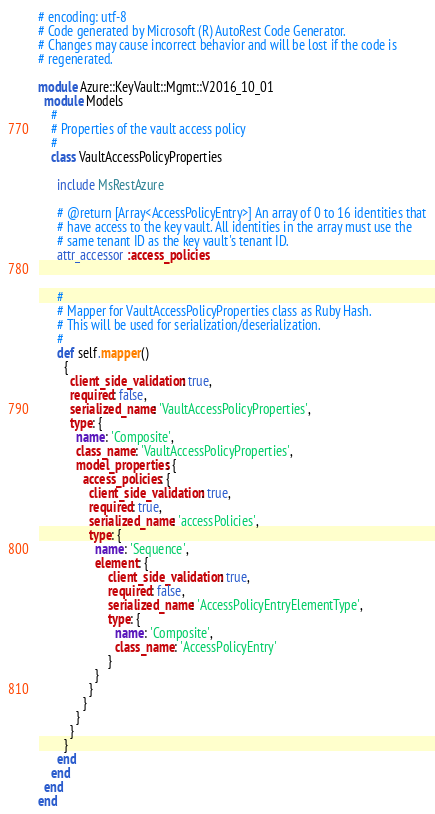Convert code to text. <code><loc_0><loc_0><loc_500><loc_500><_Ruby_># encoding: utf-8
# Code generated by Microsoft (R) AutoRest Code Generator.
# Changes may cause incorrect behavior and will be lost if the code is
# regenerated.

module Azure::KeyVault::Mgmt::V2016_10_01
  module Models
    #
    # Properties of the vault access policy
    #
    class VaultAccessPolicyProperties

      include MsRestAzure

      # @return [Array<AccessPolicyEntry>] An array of 0 to 16 identities that
      # have access to the key vault. All identities in the array must use the
      # same tenant ID as the key vault's tenant ID.
      attr_accessor :access_policies


      #
      # Mapper for VaultAccessPolicyProperties class as Ruby Hash.
      # This will be used for serialization/deserialization.
      #
      def self.mapper()
        {
          client_side_validation: true,
          required: false,
          serialized_name: 'VaultAccessPolicyProperties',
          type: {
            name: 'Composite',
            class_name: 'VaultAccessPolicyProperties',
            model_properties: {
              access_policies: {
                client_side_validation: true,
                required: true,
                serialized_name: 'accessPolicies',
                type: {
                  name: 'Sequence',
                  element: {
                      client_side_validation: true,
                      required: false,
                      serialized_name: 'AccessPolicyEntryElementType',
                      type: {
                        name: 'Composite',
                        class_name: 'AccessPolicyEntry'
                      }
                  }
                }
              }
            }
          }
        }
      end
    end
  end
end
</code> 